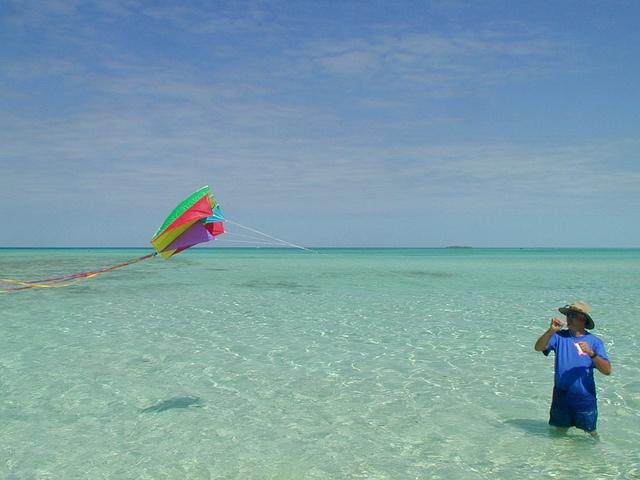Describe the objects in this image and their specific colors. I can see people in gray, navy, black, and blue tones and kite in gray, teal, darkgray, salmon, and olive tones in this image. 